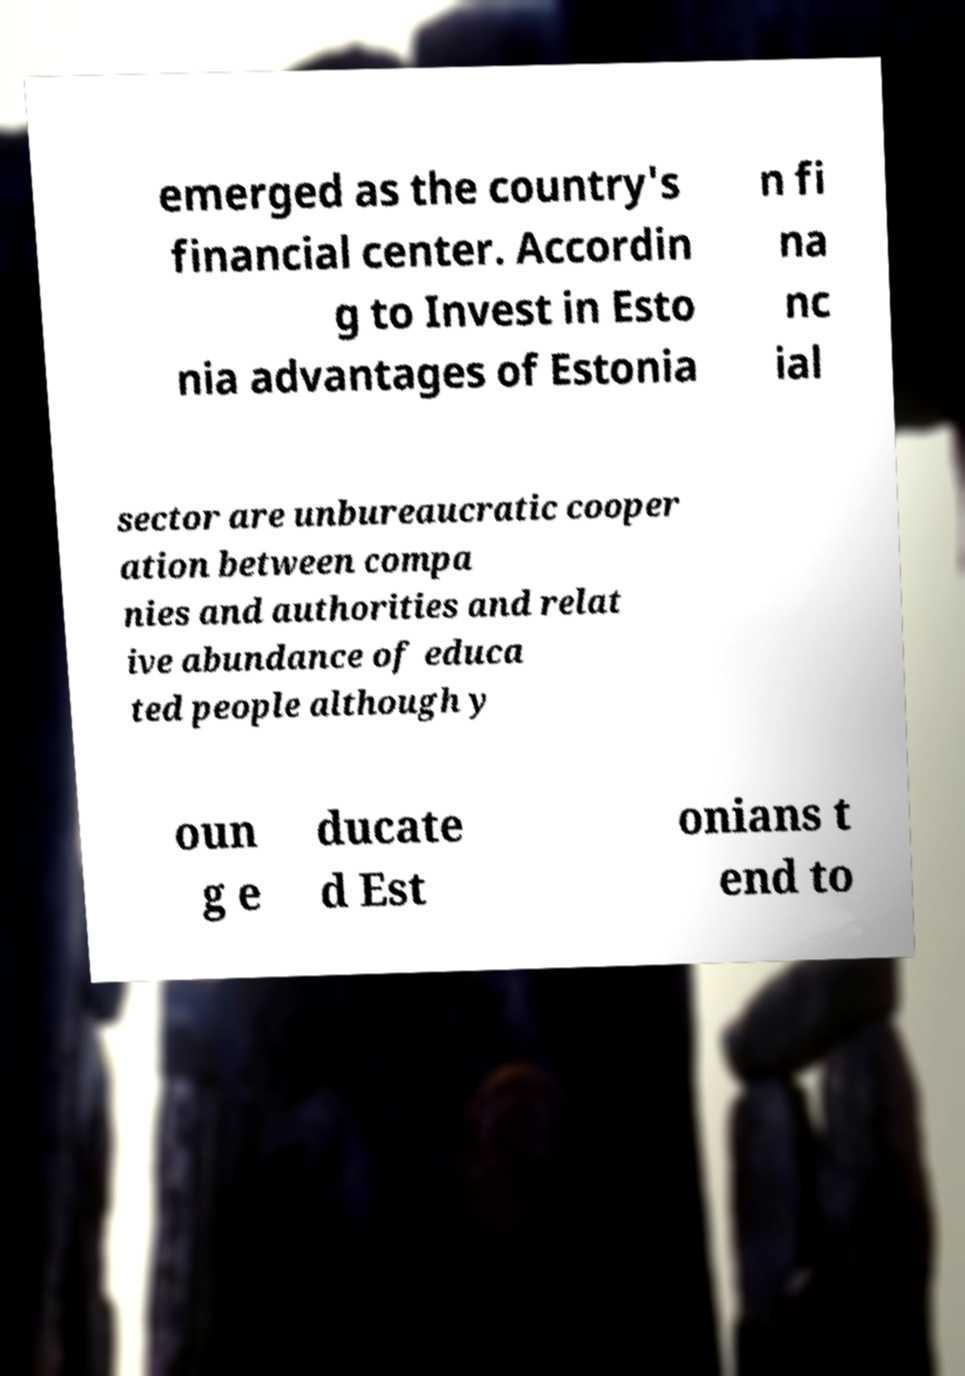Please identify and transcribe the text found in this image. emerged as the country's financial center. Accordin g to Invest in Esto nia advantages of Estonia n fi na nc ial sector are unbureaucratic cooper ation between compa nies and authorities and relat ive abundance of educa ted people although y oun g e ducate d Est onians t end to 